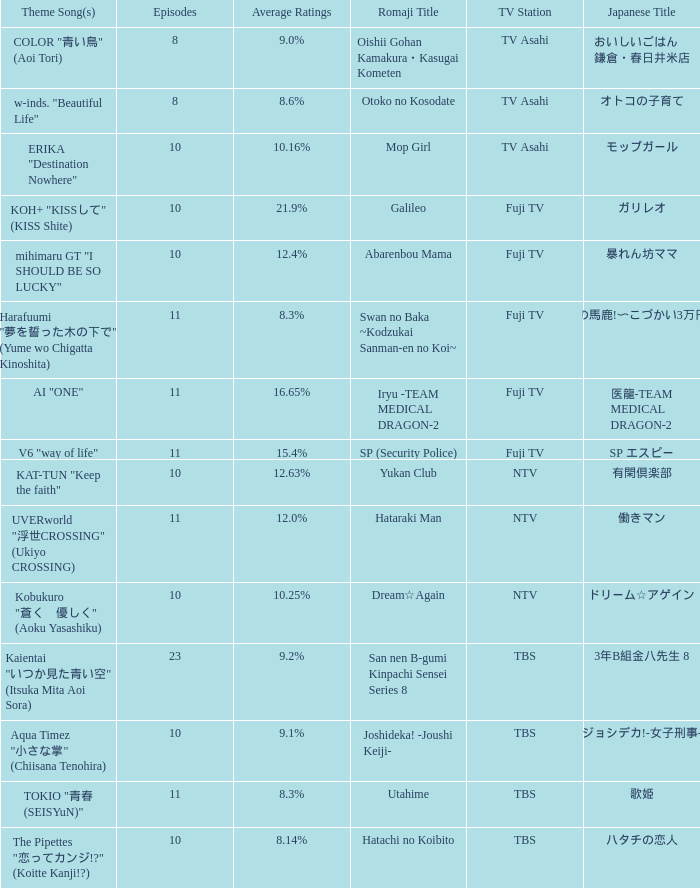What Episode has a Theme Song of koh+ "kissして" (kiss shite)? 10.0. 